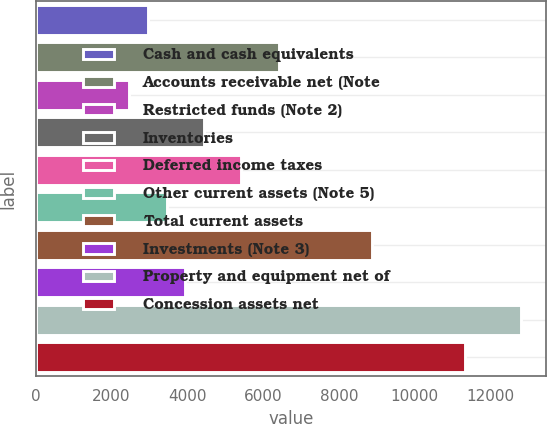<chart> <loc_0><loc_0><loc_500><loc_500><bar_chart><fcel>Cash and cash equivalents<fcel>Accounts receivable net (Note<fcel>Restricted funds (Note 2)<fcel>Inventories<fcel>Deferred income taxes<fcel>Other current assets (Note 5)<fcel>Total current assets<fcel>Investments (Note 3)<fcel>Property and equipment net of<fcel>Concession assets net<nl><fcel>2957<fcel>6406.6<fcel>2464.2<fcel>4435.4<fcel>5421<fcel>3449.8<fcel>8870.6<fcel>3942.6<fcel>12813<fcel>11334.6<nl></chart> 